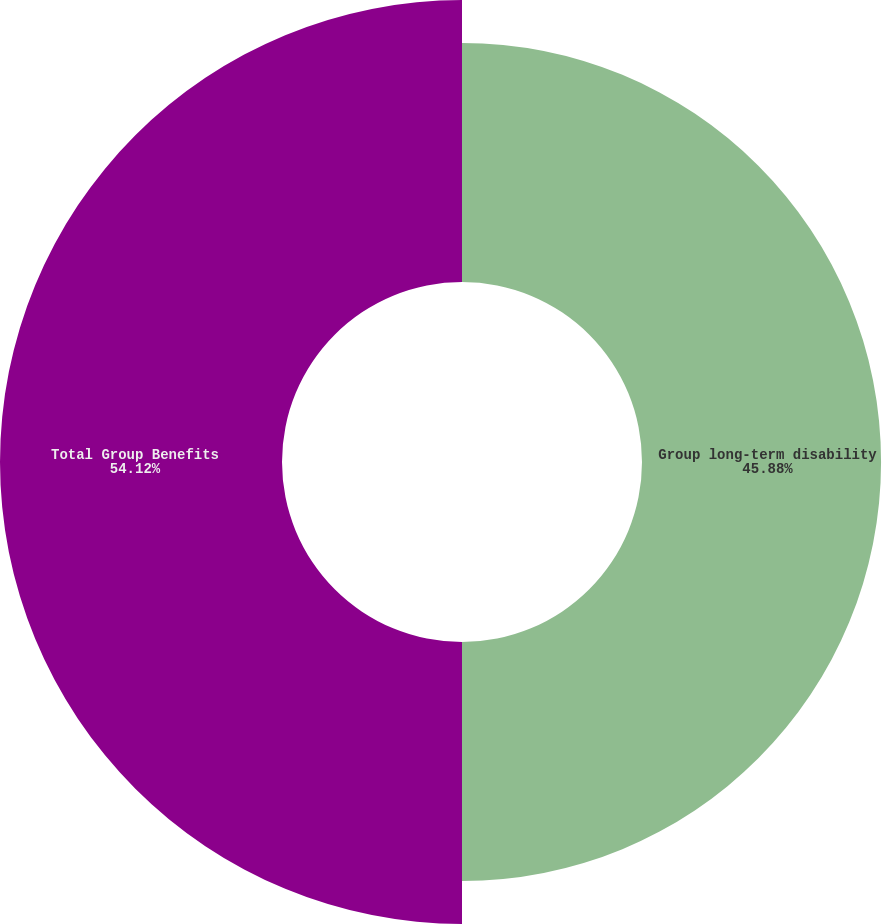Convert chart to OTSL. <chart><loc_0><loc_0><loc_500><loc_500><pie_chart><fcel>Group long-term disability<fcel>Total Group Benefits<nl><fcel>45.88%<fcel>54.12%<nl></chart> 